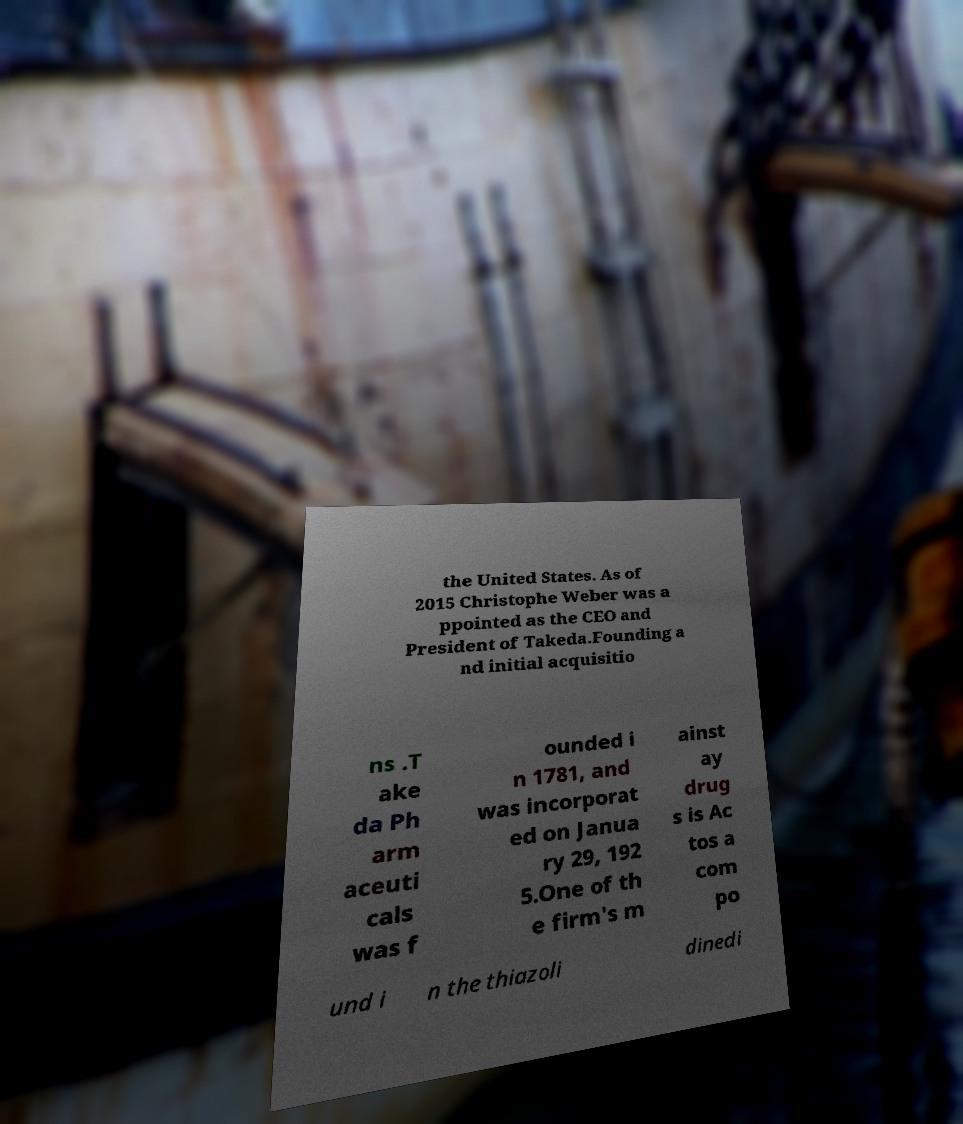Please identify and transcribe the text found in this image. the United States. As of 2015 Christophe Weber was a ppointed as the CEO and President of Takeda.Founding a nd initial acquisitio ns .T ake da Ph arm aceuti cals was f ounded i n 1781, and was incorporat ed on Janua ry 29, 192 5.One of th e firm's m ainst ay drug s is Ac tos a com po und i n the thiazoli dinedi 